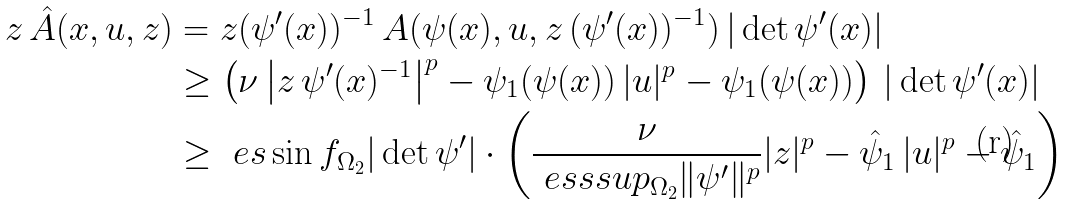<formula> <loc_0><loc_0><loc_500><loc_500>z \, \hat { A } ( x , u , z ) & = z ( \psi ^ { \prime } ( x ) ) ^ { - 1 } \, A ( \psi ( x ) , u , z \, ( \psi ^ { \prime } ( x ) ) ^ { - 1 } ) \, | \det \psi ^ { \prime } ( x ) | \\ & \geq \left ( \nu \left | z \, \psi ^ { \prime } ( x ) ^ { - 1 } \right | ^ { p } - \psi _ { 1 } ( \psi ( x ) ) \, | u | ^ { p } - \psi _ { 1 } ( \psi ( x ) ) \right ) \, | \det \psi ^ { \prime } ( x ) | \\ & \geq \ e s \sin f _ { \Omega _ { 2 } } | \det \psi ^ { \prime } | \cdot \left ( \frac { \nu } { \ e s s s u p _ { \Omega _ { 2 } } \| \psi ^ { \prime } \| ^ { p } } | z | ^ { p } - \hat { \psi } _ { 1 } \, | u | ^ { p } - \hat { \psi } _ { 1 } \right )</formula> 